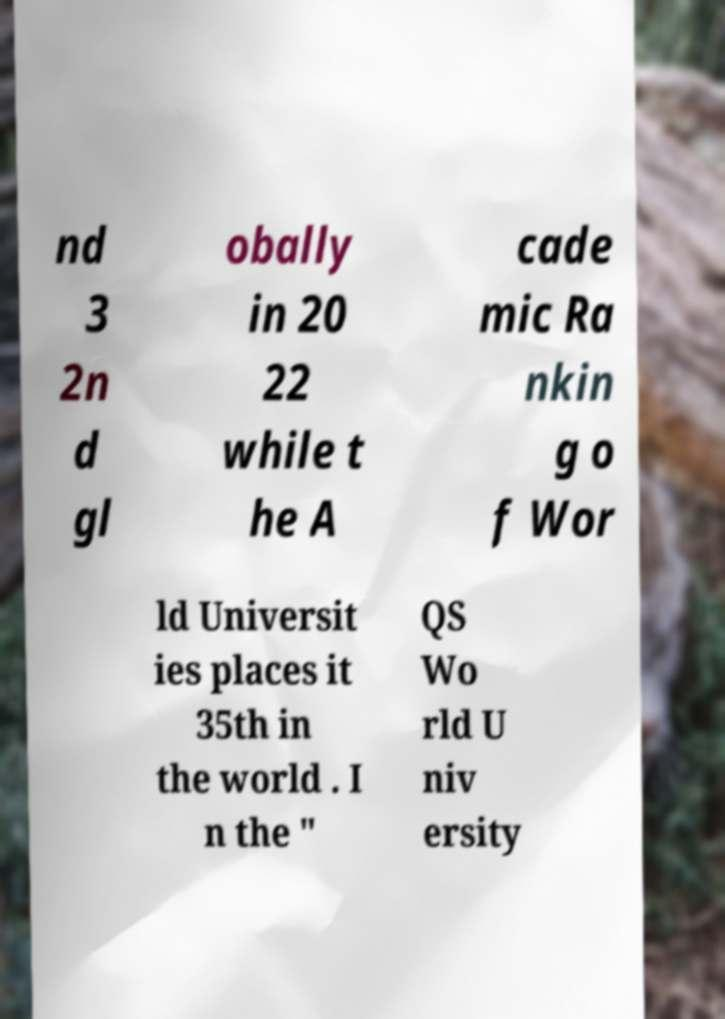Could you extract and type out the text from this image? nd 3 2n d gl obally in 20 22 while t he A cade mic Ra nkin g o f Wor ld Universit ies places it 35th in the world . I n the " QS Wo rld U niv ersity 